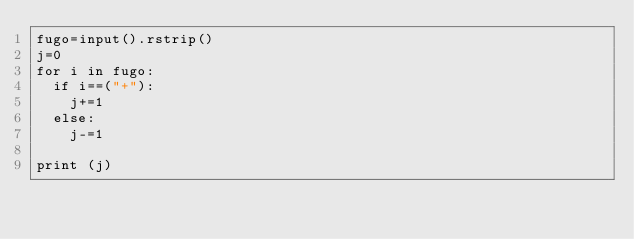Convert code to text. <code><loc_0><loc_0><loc_500><loc_500><_Python_>fugo=input().rstrip()
j=0
for i in fugo:
  if i==("+"):
    j+=1
  else:
    j-=1
    
print (j)</code> 